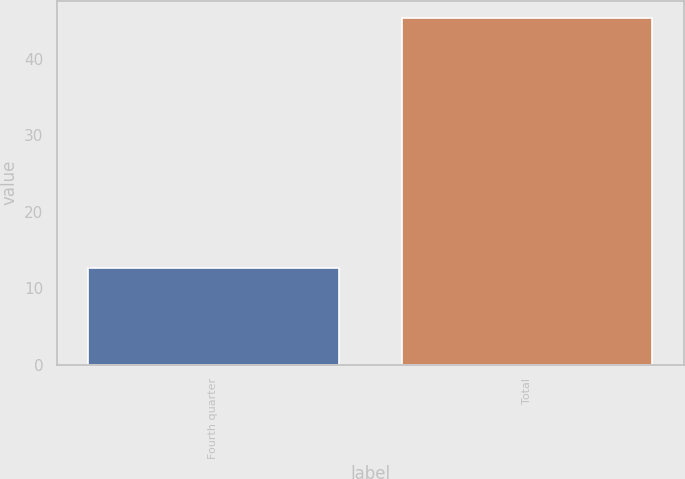Convert chart. <chart><loc_0><loc_0><loc_500><loc_500><bar_chart><fcel>Fourth quarter<fcel>Total<nl><fcel>12.6<fcel>45.3<nl></chart> 